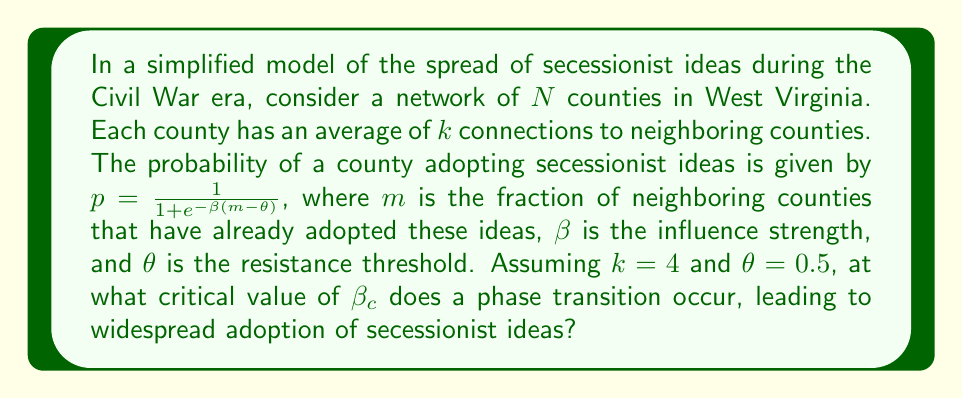Provide a solution to this math problem. To solve this problem, we'll use concepts from statistical mechanics and percolation theory:

1) In the context of idea spread, the phase transition occurs when the average number of newly converted counties per existing converted county becomes exactly 1.

2) This condition can be expressed as:
   $$(k-1) \cdot \left.\frac{dp}{dm}\right|_{m=0} = 1$$

3) We need to find $\frac{dp}{dm}$:
   $$p = \frac{1}{1 + e^{-\beta(m-\theta)}}$$
   $$\frac{dp}{dm} = \frac{\beta e^{-\beta(m-\theta)}}{(1 + e^{-\beta(m-\theta)})^2}$$

4) Evaluating at $m=0$:
   $$\left.\frac{dp}{dm}\right|_{m=0} = \frac{\beta e^{\beta\theta}}{(1 + e^{\beta\theta})^2}$$

5) Substituting into the condition from step 2:
   $$(k-1) \cdot \frac{\beta_c e^{\beta_c\theta}}{(1 + e^{\beta_c\theta})^2} = 1$$

6) Given $k=4$ and $\theta=0.5$:
   $$3 \cdot \frac{\beta_c e^{0.5\beta_c}}{(1 + e^{0.5\beta_c})^2} = 1$$

7) This transcendental equation can be solved numerically, yielding:
   $$\beta_c \approx 4.236$$

This critical value represents the minimum influence strength required for secessionist ideas to spread widely across the network of counties.
Answer: $\beta_c \approx 4.236$ 